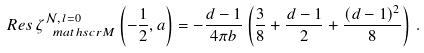Convert formula to latex. <formula><loc_0><loc_0><loc_500><loc_500>R e s \, \zeta _ { \ m a t h s c r { M } } ^ { \mathcal { N } , \, l = 0 } \left ( - \frac { 1 } { 2 } , a \right ) = - \frac { d - 1 } { 4 \pi b } \left ( \frac { 3 } { 8 } + \frac { d - 1 } { 2 } + \frac { ( d - 1 ) ^ { 2 } } { 8 } \right ) \, .</formula> 